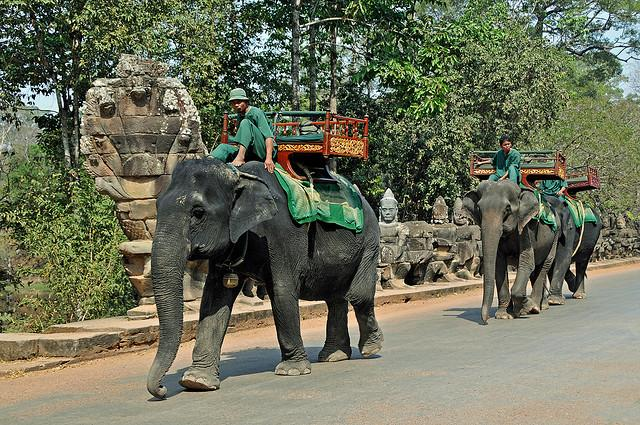Which country is famous for elephants?

Choices:
A) norway
B) sydney
C) thailand
D) dutch thailand 